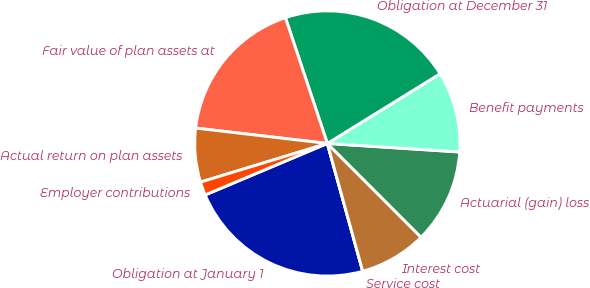Convert chart. <chart><loc_0><loc_0><loc_500><loc_500><pie_chart><fcel>Obligation at January 1<fcel>Service cost<fcel>Interest cost<fcel>Actuarial (gain) loss<fcel>Benefit payments<fcel>Obligation at December 31<fcel>Fair value of plan assets at<fcel>Actual return on plan assets<fcel>Employer contributions<nl><fcel>22.95%<fcel>0.0%<fcel>8.2%<fcel>11.48%<fcel>9.84%<fcel>21.31%<fcel>18.03%<fcel>6.56%<fcel>1.64%<nl></chart> 